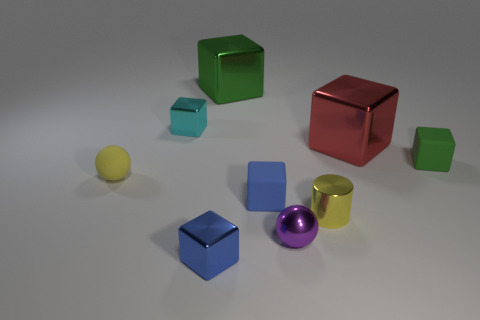Subtract all green metal blocks. How many blocks are left? 5 Subtract all blue cubes. How many cubes are left? 4 Subtract 2 blocks. How many blocks are left? 4 Add 1 small cyan shiny things. How many objects exist? 10 Subtract all blue cubes. Subtract all purple spheres. How many cubes are left? 4 Subtract all balls. How many objects are left? 7 Add 7 balls. How many balls are left? 9 Add 6 tiny blue rubber balls. How many tiny blue rubber balls exist? 6 Subtract 1 blue blocks. How many objects are left? 8 Subtract all big green rubber cylinders. Subtract all metallic blocks. How many objects are left? 5 